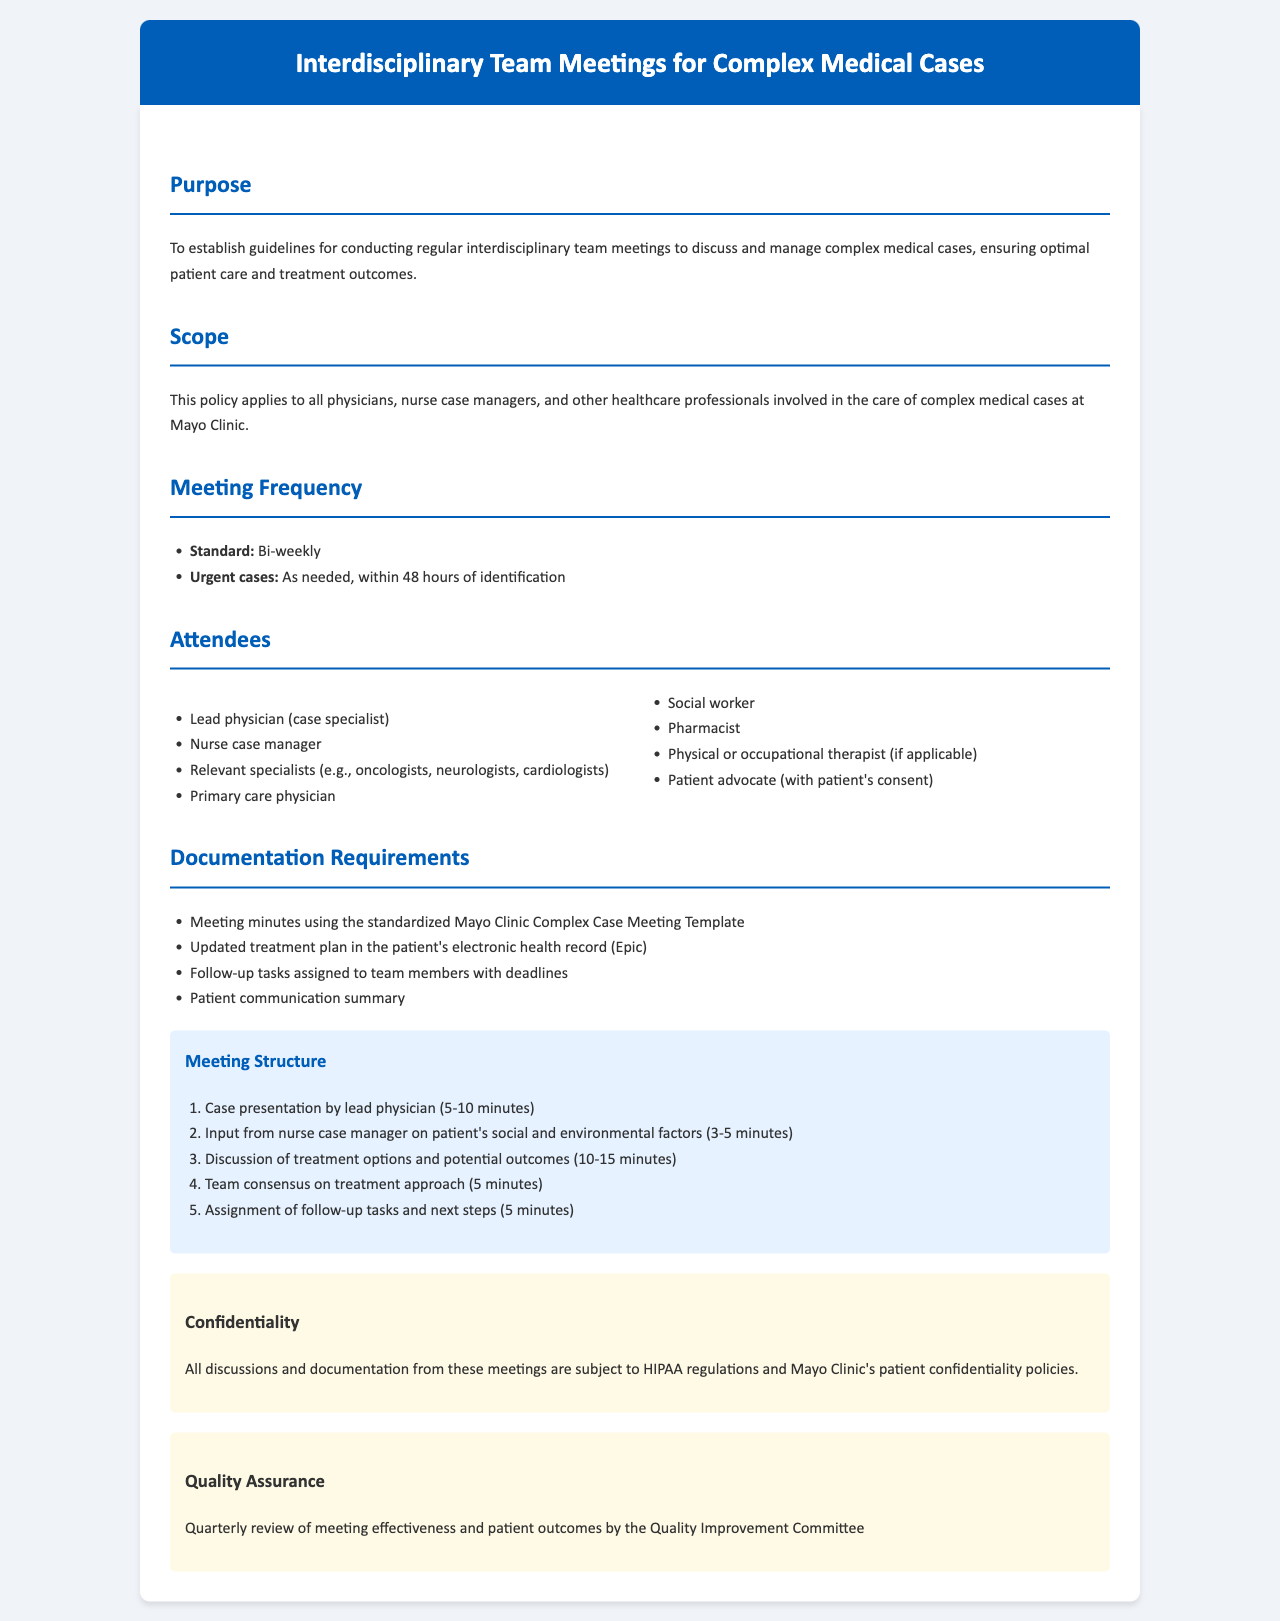What is the frequency of standard meetings? The frequency of standard meetings is mentioned in the section on Meeting Frequency, which states they occur bi-weekly.
Answer: Bi-weekly Who is the lead attendee of the meetings? The lead attendee is specified in the Attendees section as the lead physician (case specialist).
Answer: Lead physician (case specialist) How soon should urgent cases be addressed? The response timeframe for urgent cases is within 48 hours of identification, as indicated in the Meeting Frequency section.
Answer: Within 48 hours What template is used for meeting minutes? The documentation requirements state that meeting minutes must use the standardized Mayo Clinic Complex Case Meeting Template.
Answer: Standardized Mayo Clinic Complex Case Meeting Template What is the total time allocated for case presentation and input from the nurse case manager? The total time for these components is calculated by adding 5-10 minutes for case presentation and 3-5 minutes for input from the nurse case manager.
Answer: 8-15 minutes How often is the meeting effectiveness reviewed? The Quality Assurance section specifies that the review of meeting effectiveness occurs quarterly.
Answer: Quarterly Which professional is responsible for input on the patient's social factors? According to the Meeting Structure section, the nurse case manager is responsible for providing input on the patient's social factors.
Answer: Nurse case manager Is patient communication subject to any regulations? The Confidentiality section notes that all discussions and documentation are subject to HIPAA regulations, indicating that patient communication is indeed regulated.
Answer: HIPAA regulations 